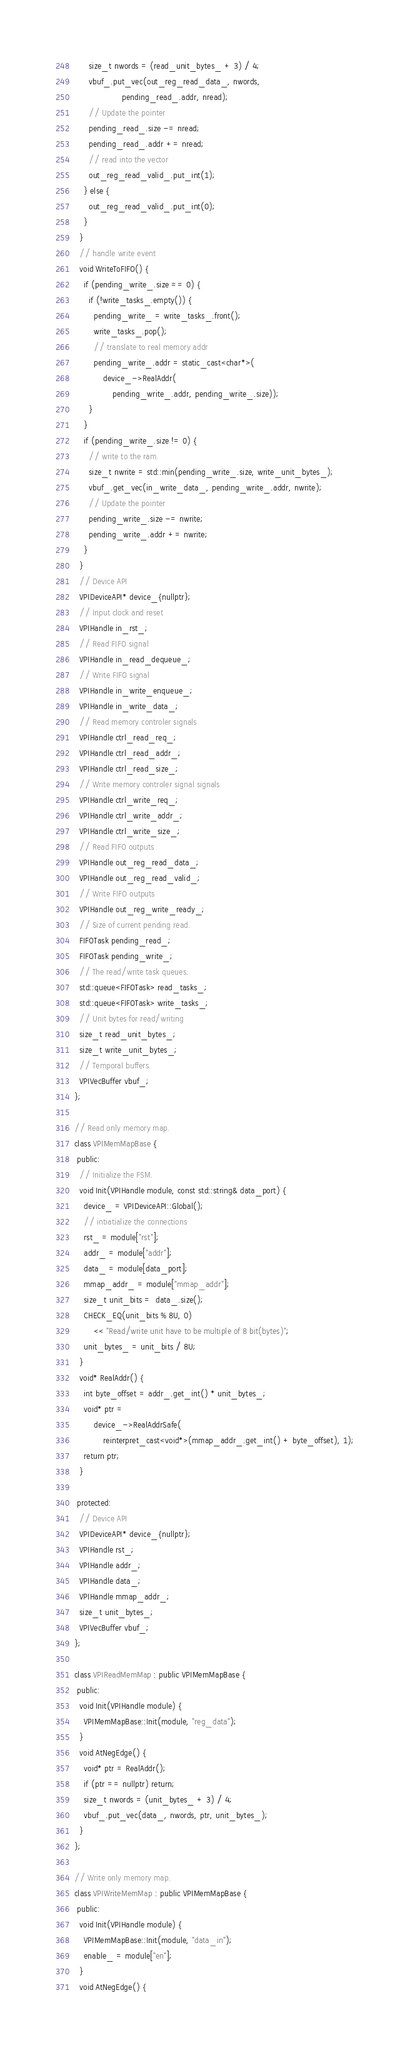Convert code to text. <code><loc_0><loc_0><loc_500><loc_500><_C++_>      size_t nwords = (read_unit_bytes_ + 3) / 4;
      vbuf_.put_vec(out_reg_read_data_, nwords,
                    pending_read_.addr, nread);
      // Update the pointer
      pending_read_.size -= nread;
      pending_read_.addr += nread;
      // read into the vector
      out_reg_read_valid_.put_int(1);
    } else {
      out_reg_read_valid_.put_int(0);
    }
  }
  // handle write event
  void WriteToFIFO() {
    if (pending_write_.size == 0) {
      if (!write_tasks_.empty()) {
        pending_write_ = write_tasks_.front();
        write_tasks_.pop();
        // translate to real memory addr
        pending_write_.addr = static_cast<char*>(
            device_->RealAddr(
                pending_write_.addr, pending_write_.size));
      }
    }
    if (pending_write_.size != 0) {
      // write to the ram.
      size_t nwrite = std::min(pending_write_.size, write_unit_bytes_);
      vbuf_.get_vec(in_write_data_, pending_write_.addr, nwrite);
      // Update the pointer
      pending_write_.size -= nwrite;
      pending_write_.addr += nwrite;
    }
  }
  // Device API
  VPIDeviceAPI* device_{nullptr};
  // Input clock and reset
  VPIHandle in_rst_;
  // Read FIFO signal
  VPIHandle in_read_dequeue_;
  // Write FIFO signal
  VPIHandle in_write_enqueue_;
  VPIHandle in_write_data_;
  // Read memory controler signals
  VPIHandle ctrl_read_req_;
  VPIHandle ctrl_read_addr_;
  VPIHandle ctrl_read_size_;
  // Write memory controler signal signals
  VPIHandle ctrl_write_req_;
  VPIHandle ctrl_write_addr_;
  VPIHandle ctrl_write_size_;
  // Read FIFO outputs
  VPIHandle out_reg_read_data_;
  VPIHandle out_reg_read_valid_;
  // Write FIFO outputs
  VPIHandle out_reg_write_ready_;
  // Size of current pending read.
  FIFOTask pending_read_;
  FIFOTask pending_write_;
  // The read/write task queues.
  std::queue<FIFOTask> read_tasks_;
  std::queue<FIFOTask> write_tasks_;
  // Unit bytes for read/writing
  size_t read_unit_bytes_;
  size_t write_unit_bytes_;
  // Temporal buffers.
  VPIVecBuffer vbuf_;
};

// Read only memory map.
class VPIMemMapBase {
 public:
  // Initialize the FSM.
  void Init(VPIHandle module, const std::string& data_port) {
    device_ = VPIDeviceAPI::Global();
    // intiatialize the connections
    rst_ = module["rst"];
    addr_ = module["addr"];
    data_ = module[data_port];
    mmap_addr_ = module["mmap_addr"];
    size_t unit_bits =  data_.size();
    CHECK_EQ(unit_bits % 8U, 0)
        << "Read/write unit have to be multiple of 8 bit(bytes)";
    unit_bytes_ = unit_bits / 8U;
  }
  void* RealAddr() {
    int byte_offset = addr_.get_int() * unit_bytes_;
    void* ptr =
        device_->RealAddrSafe(
            reinterpret_cast<void*>(mmap_addr_.get_int() + byte_offset), 1);
    return ptr;
  }

 protected:
  // Device API
  VPIDeviceAPI* device_{nullptr};
  VPIHandle rst_;
  VPIHandle addr_;
  VPIHandle data_;
  VPIHandle mmap_addr_;
  size_t unit_bytes_;
  VPIVecBuffer vbuf_;
};

class VPIReadMemMap : public VPIMemMapBase {
 public:
  void Init(VPIHandle module) {
    VPIMemMapBase::Init(module, "reg_data");
  }
  void AtNegEdge() {
    void* ptr = RealAddr();
    if (ptr == nullptr) return;
    size_t nwords = (unit_bytes_ + 3) / 4;
    vbuf_.put_vec(data_, nwords, ptr, unit_bytes_);
  }
};

// Write only memory map.
class VPIWriteMemMap : public VPIMemMapBase {
 public:
  void Init(VPIHandle module) {
    VPIMemMapBase::Init(module, "data_in");
    enable_ = module["en"];
  }
  void AtNegEdge() {</code> 